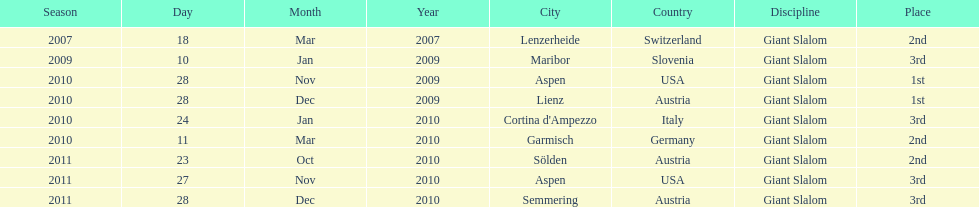How many races were in 2010? 5. 